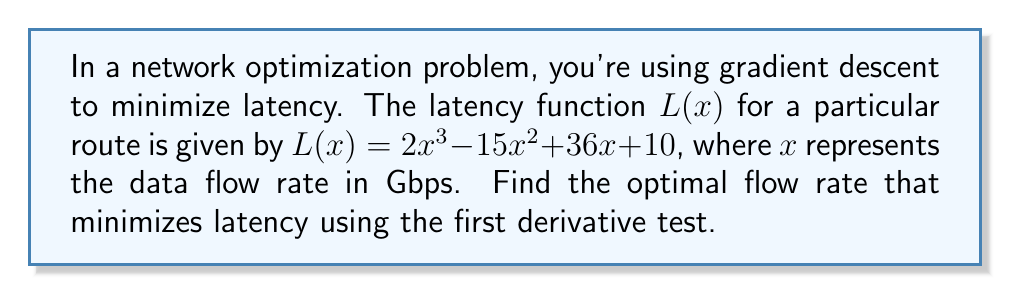Could you help me with this problem? To find the optimal flow rate that minimizes latency, we need to follow these steps:

1. Calculate the first derivative of the latency function $L(x)$:
   $$L'(x) = \frac{d}{dx}(2x^3 - 15x^2 + 36x + 10)$$
   $$L'(x) = 6x^2 - 30x + 36$$

2. Set the first derivative equal to zero to find critical points:
   $$6x^2 - 30x + 36 = 0$$

3. Solve the quadratic equation:
   $$6(x^2 - 5x + 6) = 0$$
   $$x^2 - 5x + 6 = 0$$
   
   Using the quadratic formula: $x = \frac{-b \pm \sqrt{b^2 - 4ac}}{2a}$
   
   $$x = \frac{5 \pm \sqrt{25 - 24}}{2} = \frac{5 \pm 1}{2}$$

   This gives us two critical points:
   $$x_1 = 3 \text{ and } x_2 = 2$$

4. Evaluate the second derivative to determine the nature of these critical points:
   $$L''(x) = \frac{d}{dx}(6x^2 - 30x + 36) = 12x - 30$$

   At $x_1 = 3$: $L''(3) = 12(3) - 30 = 6 > 0$ (local minimum)
   At $x_2 = 2$: $L''(2) = 12(2) - 30 = -6 < 0$ (local maximum)

5. Since we're minimizing latency, we choose the local minimum at $x = 3$ Gbps.
Answer: 3 Gbps 